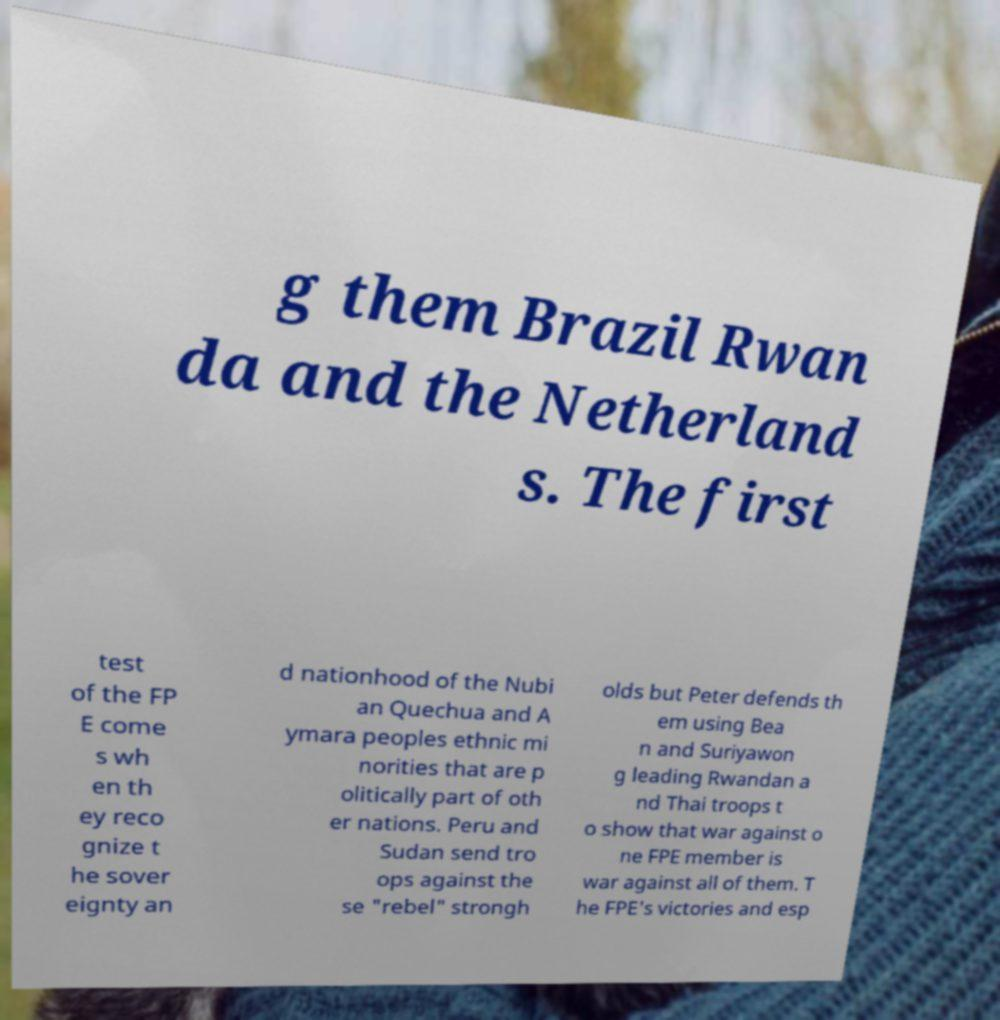For documentation purposes, I need the text within this image transcribed. Could you provide that? g them Brazil Rwan da and the Netherland s. The first test of the FP E come s wh en th ey reco gnize t he sover eignty an d nationhood of the Nubi an Quechua and A ymara peoples ethnic mi norities that are p olitically part of oth er nations. Peru and Sudan send tro ops against the se "rebel" strongh olds but Peter defends th em using Bea n and Suriyawon g leading Rwandan a nd Thai troops t o show that war against o ne FPE member is war against all of them. T he FPE's victories and esp 